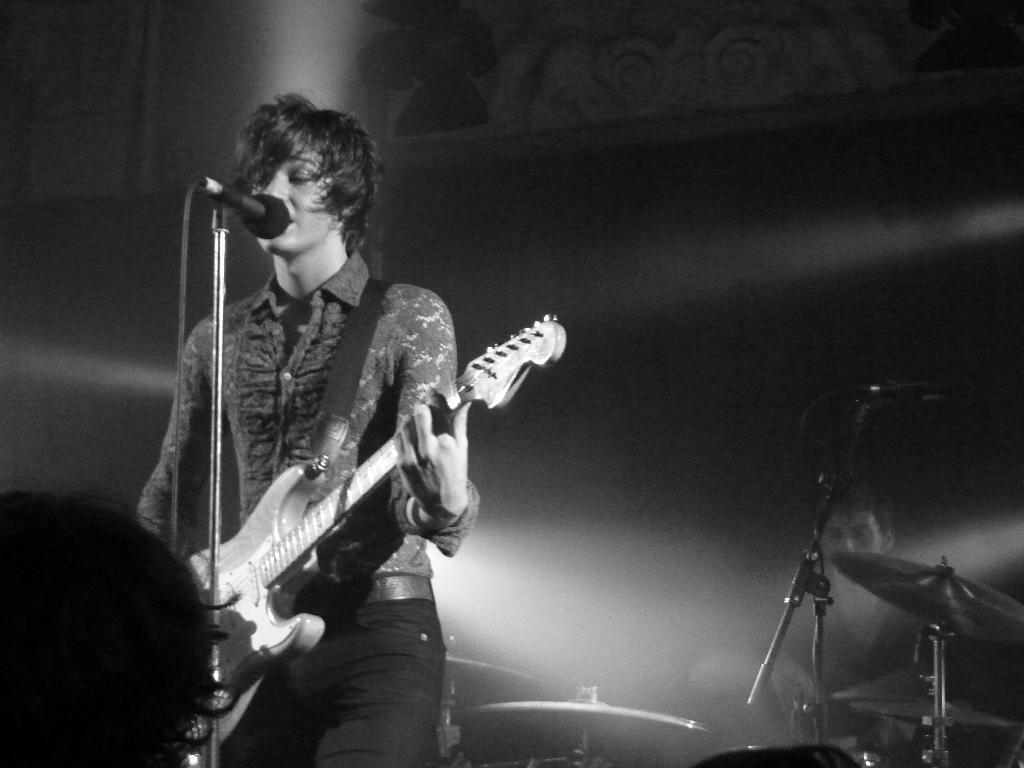Describe this image in one or two sentences. In this image I see a man who is holding a guitar and he is in front of a mic. In the background I see another person and there is a musical instrument over here. 